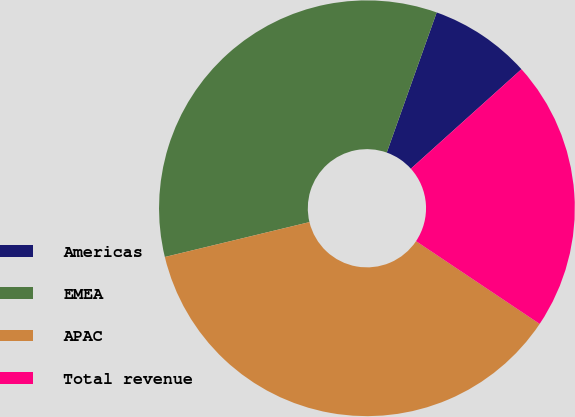Convert chart to OTSL. <chart><loc_0><loc_0><loc_500><loc_500><pie_chart><fcel>Americas<fcel>EMEA<fcel>APAC<fcel>Total revenue<nl><fcel>7.89%<fcel>34.21%<fcel>36.84%<fcel>21.05%<nl></chart> 